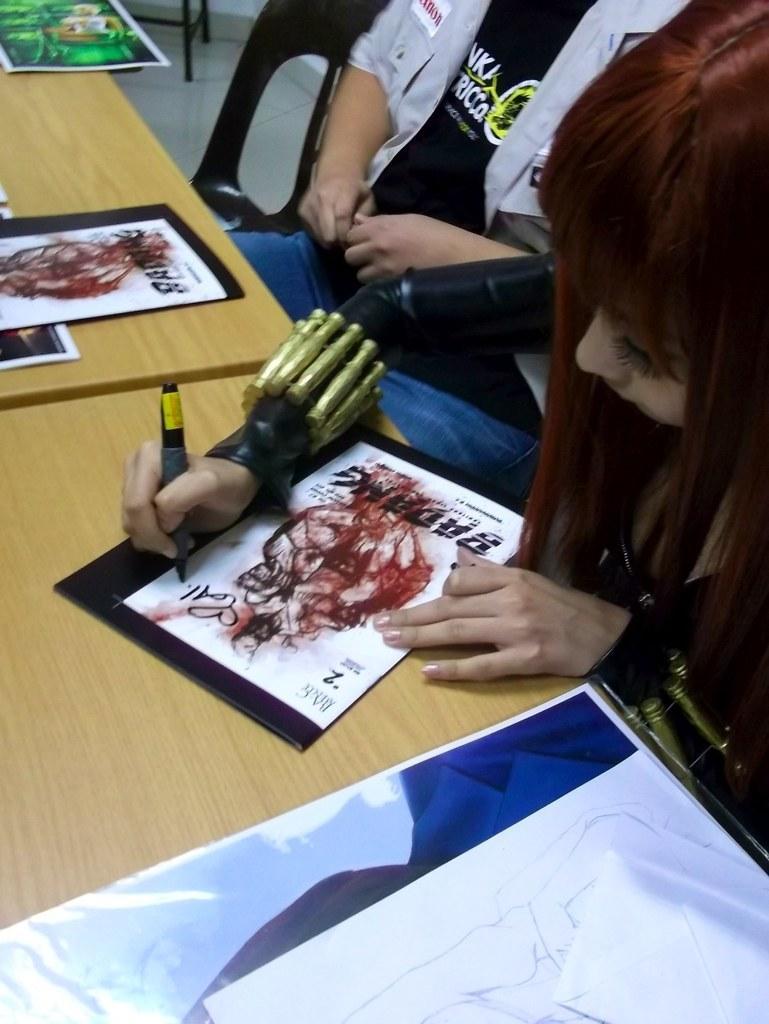Please provide a concise description of this image. In this image I can see few people are sitting and I can see she is holding a pen. I can also see few tables and on these tables I can see few papers. On these papers I can see few drawings. 